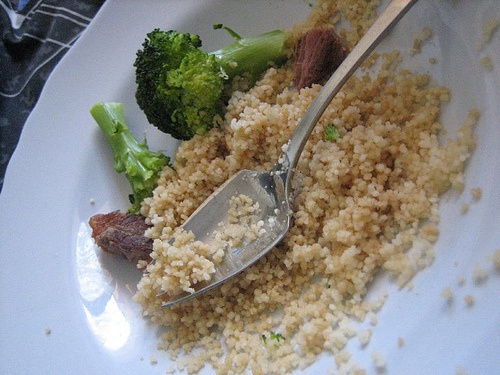Describe the objects in this image and their specific colors. I can see bowl in darkgray, gray, and tan tones, spoon in gray and darkgray tones, broccoli in gray, black, darkgreen, and olive tones, and broccoli in gray, darkgreen, olive, and darkgray tones in this image. 